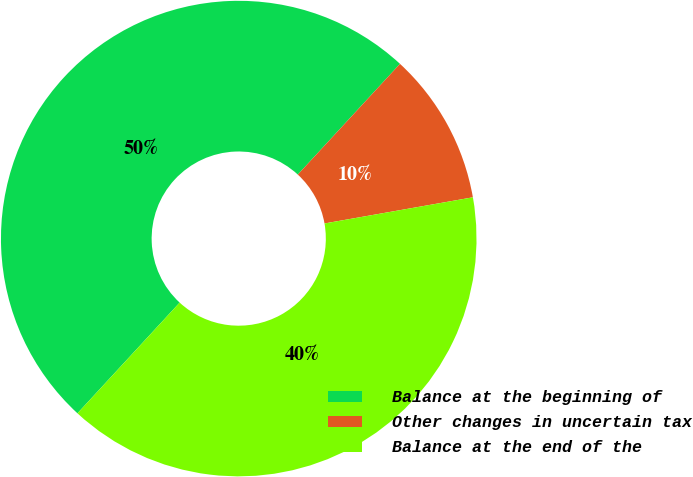Convert chart. <chart><loc_0><loc_0><loc_500><loc_500><pie_chart><fcel>Balance at the beginning of<fcel>Other changes in uncertain tax<fcel>Balance at the end of the<nl><fcel>50.0%<fcel>10.36%<fcel>39.64%<nl></chart> 